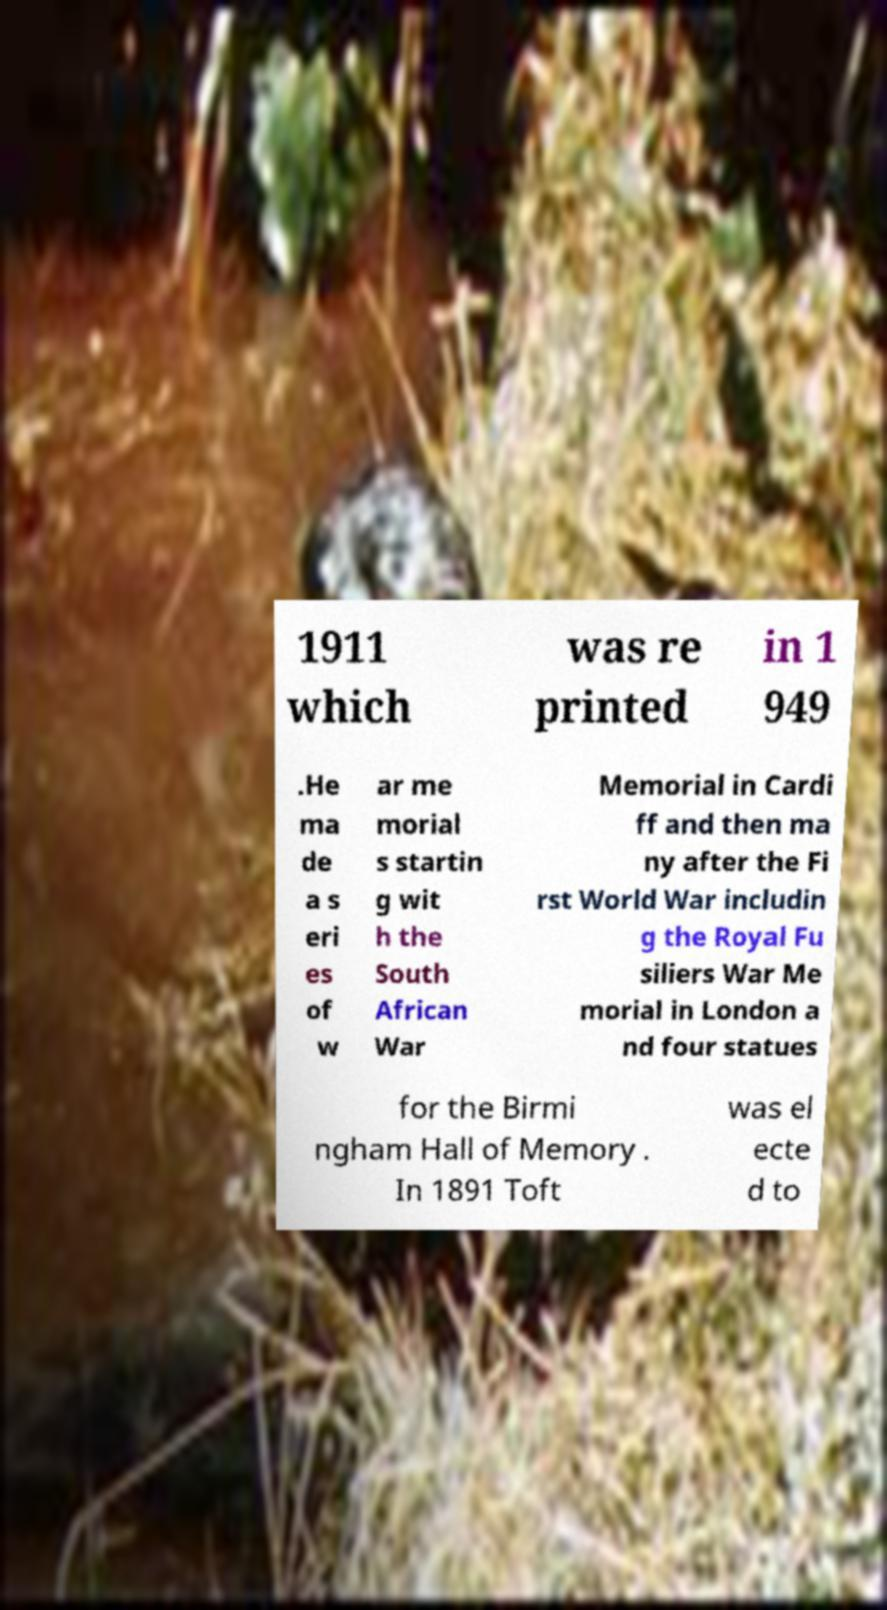Please identify and transcribe the text found in this image. 1911 which was re printed in 1 949 .He ma de a s eri es of w ar me morial s startin g wit h the South African War Memorial in Cardi ff and then ma ny after the Fi rst World War includin g the Royal Fu siliers War Me morial in London a nd four statues for the Birmi ngham Hall of Memory . In 1891 Toft was el ecte d to 